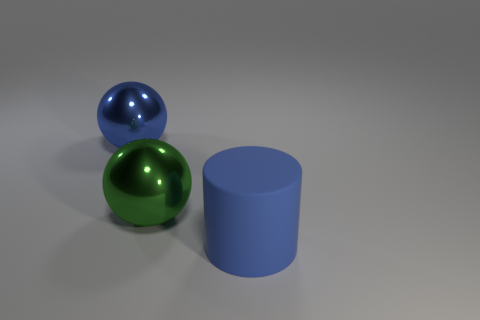Are there any other things that have the same shape as the big blue rubber thing?
Offer a terse response. No. The other thing that is the same color as the big rubber thing is what shape?
Make the answer very short. Sphere. What number of brown things are either big metal objects or cylinders?
Your answer should be compact. 0. Is the number of rubber cylinders behind the green sphere greater than the number of large blue objects?
Offer a very short reply. No. There is a big green sphere; what number of shiny balls are to the left of it?
Keep it short and to the point. 1. Are there any blue shiny balls that have the same size as the matte thing?
Provide a short and direct response. Yes. What color is the other thing that is the same shape as the large green shiny object?
Offer a terse response. Blue. Does the blue thing that is behind the large blue rubber object have the same size as the rubber cylinder that is in front of the large blue ball?
Provide a short and direct response. Yes. Is there a shiny object of the same shape as the matte object?
Ensure brevity in your answer.  No. Is the number of metal objects that are behind the big blue metal object the same as the number of green cylinders?
Keep it short and to the point. Yes. 